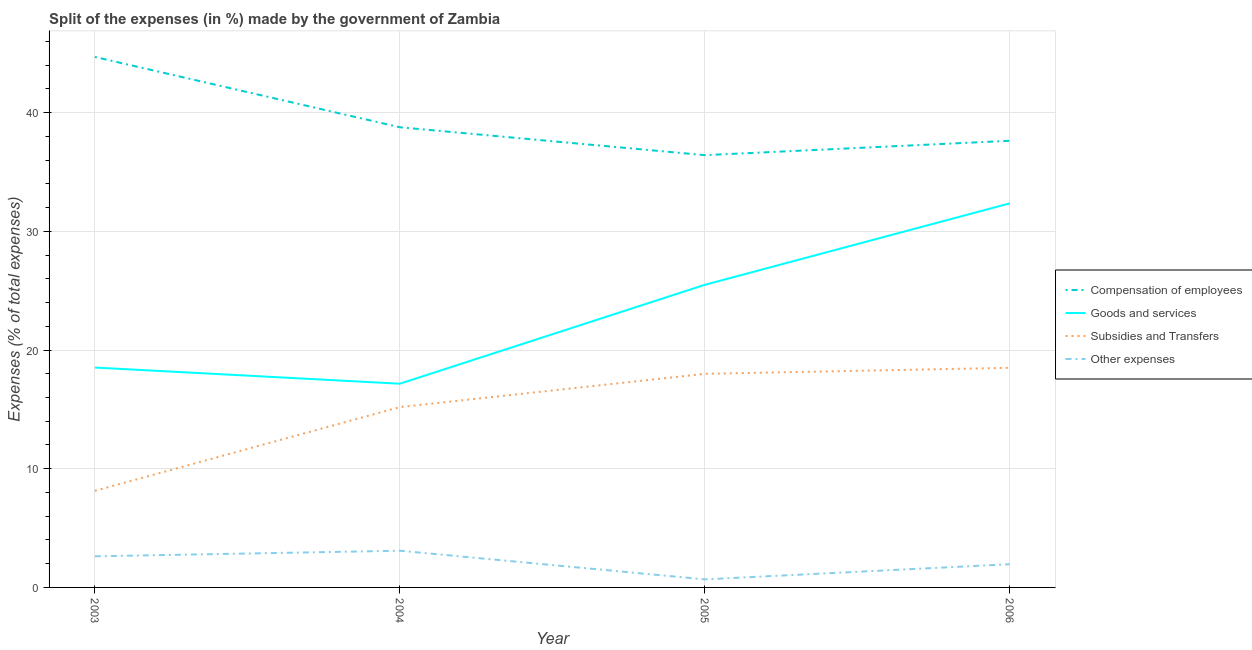How many different coloured lines are there?
Provide a short and direct response. 4. Is the number of lines equal to the number of legend labels?
Provide a short and direct response. Yes. What is the percentage of amount spent on compensation of employees in 2006?
Your response must be concise. 37.63. Across all years, what is the maximum percentage of amount spent on other expenses?
Give a very brief answer. 3.09. Across all years, what is the minimum percentage of amount spent on other expenses?
Keep it short and to the point. 0.68. What is the total percentage of amount spent on subsidies in the graph?
Give a very brief answer. 59.83. What is the difference between the percentage of amount spent on subsidies in 2003 and that in 2004?
Your response must be concise. -7.05. What is the difference between the percentage of amount spent on compensation of employees in 2006 and the percentage of amount spent on goods and services in 2005?
Offer a terse response. 12.13. What is the average percentage of amount spent on goods and services per year?
Your answer should be very brief. 23.38. In the year 2006, what is the difference between the percentage of amount spent on subsidies and percentage of amount spent on goods and services?
Offer a very short reply. -13.86. In how many years, is the percentage of amount spent on goods and services greater than 24 %?
Give a very brief answer. 2. What is the ratio of the percentage of amount spent on compensation of employees in 2005 to that in 2006?
Offer a very short reply. 0.97. Is the percentage of amount spent on compensation of employees in 2004 less than that in 2005?
Ensure brevity in your answer.  No. What is the difference between the highest and the second highest percentage of amount spent on other expenses?
Give a very brief answer. 0.47. What is the difference between the highest and the lowest percentage of amount spent on other expenses?
Offer a very short reply. 2.41. Is the percentage of amount spent on compensation of employees strictly greater than the percentage of amount spent on other expenses over the years?
Provide a succinct answer. Yes. How many lines are there?
Offer a terse response. 4. How many years are there in the graph?
Keep it short and to the point. 4. What is the difference between two consecutive major ticks on the Y-axis?
Your answer should be compact. 10. Are the values on the major ticks of Y-axis written in scientific E-notation?
Offer a very short reply. No. Does the graph contain any zero values?
Offer a terse response. No. Where does the legend appear in the graph?
Your response must be concise. Center right. How many legend labels are there?
Keep it short and to the point. 4. What is the title of the graph?
Keep it short and to the point. Split of the expenses (in %) made by the government of Zambia. What is the label or title of the Y-axis?
Provide a short and direct response. Expenses (% of total expenses). What is the Expenses (% of total expenses) of Compensation of employees in 2003?
Your answer should be compact. 44.69. What is the Expenses (% of total expenses) of Goods and services in 2003?
Your answer should be compact. 18.52. What is the Expenses (% of total expenses) of Subsidies and Transfers in 2003?
Make the answer very short. 8.14. What is the Expenses (% of total expenses) of Other expenses in 2003?
Your response must be concise. 2.62. What is the Expenses (% of total expenses) of Compensation of employees in 2004?
Keep it short and to the point. 38.77. What is the Expenses (% of total expenses) in Goods and services in 2004?
Provide a short and direct response. 17.16. What is the Expenses (% of total expenses) of Subsidies and Transfers in 2004?
Ensure brevity in your answer.  15.19. What is the Expenses (% of total expenses) in Other expenses in 2004?
Offer a very short reply. 3.09. What is the Expenses (% of total expenses) in Compensation of employees in 2005?
Provide a succinct answer. 36.42. What is the Expenses (% of total expenses) of Goods and services in 2005?
Provide a short and direct response. 25.49. What is the Expenses (% of total expenses) of Subsidies and Transfers in 2005?
Your response must be concise. 18. What is the Expenses (% of total expenses) of Other expenses in 2005?
Offer a very short reply. 0.68. What is the Expenses (% of total expenses) of Compensation of employees in 2006?
Offer a very short reply. 37.63. What is the Expenses (% of total expenses) in Goods and services in 2006?
Ensure brevity in your answer.  32.36. What is the Expenses (% of total expenses) in Subsidies and Transfers in 2006?
Your answer should be compact. 18.5. What is the Expenses (% of total expenses) of Other expenses in 2006?
Give a very brief answer. 1.96. Across all years, what is the maximum Expenses (% of total expenses) in Compensation of employees?
Provide a short and direct response. 44.69. Across all years, what is the maximum Expenses (% of total expenses) in Goods and services?
Keep it short and to the point. 32.36. Across all years, what is the maximum Expenses (% of total expenses) of Subsidies and Transfers?
Your response must be concise. 18.5. Across all years, what is the maximum Expenses (% of total expenses) in Other expenses?
Your response must be concise. 3.09. Across all years, what is the minimum Expenses (% of total expenses) of Compensation of employees?
Offer a very short reply. 36.42. Across all years, what is the minimum Expenses (% of total expenses) in Goods and services?
Keep it short and to the point. 17.16. Across all years, what is the minimum Expenses (% of total expenses) in Subsidies and Transfers?
Your answer should be compact. 8.14. Across all years, what is the minimum Expenses (% of total expenses) of Other expenses?
Give a very brief answer. 0.68. What is the total Expenses (% of total expenses) in Compensation of employees in the graph?
Give a very brief answer. 157.51. What is the total Expenses (% of total expenses) of Goods and services in the graph?
Offer a very short reply. 93.54. What is the total Expenses (% of total expenses) in Subsidies and Transfers in the graph?
Make the answer very short. 59.83. What is the total Expenses (% of total expenses) of Other expenses in the graph?
Offer a very short reply. 8.35. What is the difference between the Expenses (% of total expenses) of Compensation of employees in 2003 and that in 2004?
Offer a very short reply. 5.92. What is the difference between the Expenses (% of total expenses) in Goods and services in 2003 and that in 2004?
Ensure brevity in your answer.  1.36. What is the difference between the Expenses (% of total expenses) in Subsidies and Transfers in 2003 and that in 2004?
Keep it short and to the point. -7.05. What is the difference between the Expenses (% of total expenses) in Other expenses in 2003 and that in 2004?
Make the answer very short. -0.47. What is the difference between the Expenses (% of total expenses) in Compensation of employees in 2003 and that in 2005?
Your response must be concise. 8.27. What is the difference between the Expenses (% of total expenses) of Goods and services in 2003 and that in 2005?
Make the answer very short. -6.97. What is the difference between the Expenses (% of total expenses) of Subsidies and Transfers in 2003 and that in 2005?
Your response must be concise. -9.86. What is the difference between the Expenses (% of total expenses) in Other expenses in 2003 and that in 2005?
Keep it short and to the point. 1.94. What is the difference between the Expenses (% of total expenses) in Compensation of employees in 2003 and that in 2006?
Keep it short and to the point. 7.06. What is the difference between the Expenses (% of total expenses) in Goods and services in 2003 and that in 2006?
Provide a short and direct response. -13.83. What is the difference between the Expenses (% of total expenses) of Subsidies and Transfers in 2003 and that in 2006?
Give a very brief answer. -10.36. What is the difference between the Expenses (% of total expenses) in Other expenses in 2003 and that in 2006?
Your response must be concise. 0.66. What is the difference between the Expenses (% of total expenses) in Compensation of employees in 2004 and that in 2005?
Your answer should be very brief. 2.35. What is the difference between the Expenses (% of total expenses) of Goods and services in 2004 and that in 2005?
Provide a short and direct response. -8.33. What is the difference between the Expenses (% of total expenses) of Subsidies and Transfers in 2004 and that in 2005?
Offer a terse response. -2.8. What is the difference between the Expenses (% of total expenses) of Other expenses in 2004 and that in 2005?
Offer a terse response. 2.42. What is the difference between the Expenses (% of total expenses) in Compensation of employees in 2004 and that in 2006?
Your response must be concise. 1.14. What is the difference between the Expenses (% of total expenses) of Goods and services in 2004 and that in 2006?
Make the answer very short. -15.19. What is the difference between the Expenses (% of total expenses) of Subsidies and Transfers in 2004 and that in 2006?
Offer a terse response. -3.31. What is the difference between the Expenses (% of total expenses) in Other expenses in 2004 and that in 2006?
Ensure brevity in your answer.  1.13. What is the difference between the Expenses (% of total expenses) of Compensation of employees in 2005 and that in 2006?
Your answer should be compact. -1.21. What is the difference between the Expenses (% of total expenses) in Goods and services in 2005 and that in 2006?
Offer a very short reply. -6.86. What is the difference between the Expenses (% of total expenses) in Subsidies and Transfers in 2005 and that in 2006?
Provide a short and direct response. -0.51. What is the difference between the Expenses (% of total expenses) in Other expenses in 2005 and that in 2006?
Provide a succinct answer. -1.28. What is the difference between the Expenses (% of total expenses) in Compensation of employees in 2003 and the Expenses (% of total expenses) in Goods and services in 2004?
Give a very brief answer. 27.53. What is the difference between the Expenses (% of total expenses) in Compensation of employees in 2003 and the Expenses (% of total expenses) in Subsidies and Transfers in 2004?
Make the answer very short. 29.5. What is the difference between the Expenses (% of total expenses) in Compensation of employees in 2003 and the Expenses (% of total expenses) in Other expenses in 2004?
Your answer should be very brief. 41.6. What is the difference between the Expenses (% of total expenses) in Goods and services in 2003 and the Expenses (% of total expenses) in Subsidies and Transfers in 2004?
Your response must be concise. 3.33. What is the difference between the Expenses (% of total expenses) of Goods and services in 2003 and the Expenses (% of total expenses) of Other expenses in 2004?
Your answer should be compact. 15.43. What is the difference between the Expenses (% of total expenses) of Subsidies and Transfers in 2003 and the Expenses (% of total expenses) of Other expenses in 2004?
Offer a very short reply. 5.04. What is the difference between the Expenses (% of total expenses) in Compensation of employees in 2003 and the Expenses (% of total expenses) in Goods and services in 2005?
Keep it short and to the point. 19.2. What is the difference between the Expenses (% of total expenses) of Compensation of employees in 2003 and the Expenses (% of total expenses) of Subsidies and Transfers in 2005?
Your answer should be compact. 26.7. What is the difference between the Expenses (% of total expenses) in Compensation of employees in 2003 and the Expenses (% of total expenses) in Other expenses in 2005?
Keep it short and to the point. 44.01. What is the difference between the Expenses (% of total expenses) in Goods and services in 2003 and the Expenses (% of total expenses) in Subsidies and Transfers in 2005?
Offer a terse response. 0.53. What is the difference between the Expenses (% of total expenses) of Goods and services in 2003 and the Expenses (% of total expenses) of Other expenses in 2005?
Keep it short and to the point. 17.85. What is the difference between the Expenses (% of total expenses) of Subsidies and Transfers in 2003 and the Expenses (% of total expenses) of Other expenses in 2005?
Keep it short and to the point. 7.46. What is the difference between the Expenses (% of total expenses) in Compensation of employees in 2003 and the Expenses (% of total expenses) in Goods and services in 2006?
Your answer should be very brief. 12.33. What is the difference between the Expenses (% of total expenses) of Compensation of employees in 2003 and the Expenses (% of total expenses) of Subsidies and Transfers in 2006?
Ensure brevity in your answer.  26.19. What is the difference between the Expenses (% of total expenses) of Compensation of employees in 2003 and the Expenses (% of total expenses) of Other expenses in 2006?
Your answer should be compact. 42.73. What is the difference between the Expenses (% of total expenses) in Goods and services in 2003 and the Expenses (% of total expenses) in Subsidies and Transfers in 2006?
Offer a terse response. 0.02. What is the difference between the Expenses (% of total expenses) of Goods and services in 2003 and the Expenses (% of total expenses) of Other expenses in 2006?
Ensure brevity in your answer.  16.57. What is the difference between the Expenses (% of total expenses) in Subsidies and Transfers in 2003 and the Expenses (% of total expenses) in Other expenses in 2006?
Ensure brevity in your answer.  6.18. What is the difference between the Expenses (% of total expenses) of Compensation of employees in 2004 and the Expenses (% of total expenses) of Goods and services in 2005?
Provide a short and direct response. 13.27. What is the difference between the Expenses (% of total expenses) of Compensation of employees in 2004 and the Expenses (% of total expenses) of Subsidies and Transfers in 2005?
Provide a short and direct response. 20.77. What is the difference between the Expenses (% of total expenses) in Compensation of employees in 2004 and the Expenses (% of total expenses) in Other expenses in 2005?
Offer a terse response. 38.09. What is the difference between the Expenses (% of total expenses) in Goods and services in 2004 and the Expenses (% of total expenses) in Subsidies and Transfers in 2005?
Give a very brief answer. -0.83. What is the difference between the Expenses (% of total expenses) in Goods and services in 2004 and the Expenses (% of total expenses) in Other expenses in 2005?
Provide a short and direct response. 16.49. What is the difference between the Expenses (% of total expenses) of Subsidies and Transfers in 2004 and the Expenses (% of total expenses) of Other expenses in 2005?
Your answer should be very brief. 14.51. What is the difference between the Expenses (% of total expenses) in Compensation of employees in 2004 and the Expenses (% of total expenses) in Goods and services in 2006?
Ensure brevity in your answer.  6.41. What is the difference between the Expenses (% of total expenses) in Compensation of employees in 2004 and the Expenses (% of total expenses) in Subsidies and Transfers in 2006?
Provide a short and direct response. 20.27. What is the difference between the Expenses (% of total expenses) in Compensation of employees in 2004 and the Expenses (% of total expenses) in Other expenses in 2006?
Provide a succinct answer. 36.81. What is the difference between the Expenses (% of total expenses) of Goods and services in 2004 and the Expenses (% of total expenses) of Subsidies and Transfers in 2006?
Provide a succinct answer. -1.34. What is the difference between the Expenses (% of total expenses) in Goods and services in 2004 and the Expenses (% of total expenses) in Other expenses in 2006?
Offer a very short reply. 15.2. What is the difference between the Expenses (% of total expenses) in Subsidies and Transfers in 2004 and the Expenses (% of total expenses) in Other expenses in 2006?
Make the answer very short. 13.23. What is the difference between the Expenses (% of total expenses) in Compensation of employees in 2005 and the Expenses (% of total expenses) in Goods and services in 2006?
Make the answer very short. 4.06. What is the difference between the Expenses (% of total expenses) in Compensation of employees in 2005 and the Expenses (% of total expenses) in Subsidies and Transfers in 2006?
Provide a short and direct response. 17.92. What is the difference between the Expenses (% of total expenses) of Compensation of employees in 2005 and the Expenses (% of total expenses) of Other expenses in 2006?
Your answer should be very brief. 34.46. What is the difference between the Expenses (% of total expenses) of Goods and services in 2005 and the Expenses (% of total expenses) of Subsidies and Transfers in 2006?
Offer a terse response. 6.99. What is the difference between the Expenses (% of total expenses) in Goods and services in 2005 and the Expenses (% of total expenses) in Other expenses in 2006?
Your response must be concise. 23.54. What is the difference between the Expenses (% of total expenses) of Subsidies and Transfers in 2005 and the Expenses (% of total expenses) of Other expenses in 2006?
Your answer should be compact. 16.04. What is the average Expenses (% of total expenses) of Compensation of employees per year?
Your answer should be compact. 39.38. What is the average Expenses (% of total expenses) of Goods and services per year?
Keep it short and to the point. 23.38. What is the average Expenses (% of total expenses) of Subsidies and Transfers per year?
Ensure brevity in your answer.  14.96. What is the average Expenses (% of total expenses) in Other expenses per year?
Provide a short and direct response. 2.09. In the year 2003, what is the difference between the Expenses (% of total expenses) in Compensation of employees and Expenses (% of total expenses) in Goods and services?
Provide a short and direct response. 26.17. In the year 2003, what is the difference between the Expenses (% of total expenses) in Compensation of employees and Expenses (% of total expenses) in Subsidies and Transfers?
Offer a terse response. 36.55. In the year 2003, what is the difference between the Expenses (% of total expenses) in Compensation of employees and Expenses (% of total expenses) in Other expenses?
Your answer should be very brief. 42.07. In the year 2003, what is the difference between the Expenses (% of total expenses) in Goods and services and Expenses (% of total expenses) in Subsidies and Transfers?
Your answer should be very brief. 10.39. In the year 2003, what is the difference between the Expenses (% of total expenses) in Goods and services and Expenses (% of total expenses) in Other expenses?
Offer a terse response. 15.9. In the year 2003, what is the difference between the Expenses (% of total expenses) of Subsidies and Transfers and Expenses (% of total expenses) of Other expenses?
Your answer should be compact. 5.52. In the year 2004, what is the difference between the Expenses (% of total expenses) in Compensation of employees and Expenses (% of total expenses) in Goods and services?
Provide a short and direct response. 21.61. In the year 2004, what is the difference between the Expenses (% of total expenses) in Compensation of employees and Expenses (% of total expenses) in Subsidies and Transfers?
Provide a succinct answer. 23.58. In the year 2004, what is the difference between the Expenses (% of total expenses) of Compensation of employees and Expenses (% of total expenses) of Other expenses?
Your answer should be compact. 35.68. In the year 2004, what is the difference between the Expenses (% of total expenses) in Goods and services and Expenses (% of total expenses) in Subsidies and Transfers?
Provide a short and direct response. 1.97. In the year 2004, what is the difference between the Expenses (% of total expenses) in Goods and services and Expenses (% of total expenses) in Other expenses?
Offer a terse response. 14.07. In the year 2004, what is the difference between the Expenses (% of total expenses) of Subsidies and Transfers and Expenses (% of total expenses) of Other expenses?
Ensure brevity in your answer.  12.1. In the year 2005, what is the difference between the Expenses (% of total expenses) in Compensation of employees and Expenses (% of total expenses) in Goods and services?
Provide a short and direct response. 10.92. In the year 2005, what is the difference between the Expenses (% of total expenses) in Compensation of employees and Expenses (% of total expenses) in Subsidies and Transfers?
Offer a terse response. 18.42. In the year 2005, what is the difference between the Expenses (% of total expenses) of Compensation of employees and Expenses (% of total expenses) of Other expenses?
Offer a terse response. 35.74. In the year 2005, what is the difference between the Expenses (% of total expenses) of Goods and services and Expenses (% of total expenses) of Subsidies and Transfers?
Your answer should be compact. 7.5. In the year 2005, what is the difference between the Expenses (% of total expenses) in Goods and services and Expenses (% of total expenses) in Other expenses?
Provide a succinct answer. 24.82. In the year 2005, what is the difference between the Expenses (% of total expenses) in Subsidies and Transfers and Expenses (% of total expenses) in Other expenses?
Give a very brief answer. 17.32. In the year 2006, what is the difference between the Expenses (% of total expenses) in Compensation of employees and Expenses (% of total expenses) in Goods and services?
Offer a very short reply. 5.27. In the year 2006, what is the difference between the Expenses (% of total expenses) in Compensation of employees and Expenses (% of total expenses) in Subsidies and Transfers?
Provide a succinct answer. 19.13. In the year 2006, what is the difference between the Expenses (% of total expenses) of Compensation of employees and Expenses (% of total expenses) of Other expenses?
Your answer should be compact. 35.67. In the year 2006, what is the difference between the Expenses (% of total expenses) in Goods and services and Expenses (% of total expenses) in Subsidies and Transfers?
Your answer should be very brief. 13.86. In the year 2006, what is the difference between the Expenses (% of total expenses) in Goods and services and Expenses (% of total expenses) in Other expenses?
Offer a terse response. 30.4. In the year 2006, what is the difference between the Expenses (% of total expenses) of Subsidies and Transfers and Expenses (% of total expenses) of Other expenses?
Ensure brevity in your answer.  16.54. What is the ratio of the Expenses (% of total expenses) of Compensation of employees in 2003 to that in 2004?
Make the answer very short. 1.15. What is the ratio of the Expenses (% of total expenses) in Goods and services in 2003 to that in 2004?
Keep it short and to the point. 1.08. What is the ratio of the Expenses (% of total expenses) in Subsidies and Transfers in 2003 to that in 2004?
Offer a terse response. 0.54. What is the ratio of the Expenses (% of total expenses) in Other expenses in 2003 to that in 2004?
Provide a succinct answer. 0.85. What is the ratio of the Expenses (% of total expenses) in Compensation of employees in 2003 to that in 2005?
Provide a short and direct response. 1.23. What is the ratio of the Expenses (% of total expenses) in Goods and services in 2003 to that in 2005?
Offer a very short reply. 0.73. What is the ratio of the Expenses (% of total expenses) of Subsidies and Transfers in 2003 to that in 2005?
Provide a succinct answer. 0.45. What is the ratio of the Expenses (% of total expenses) in Other expenses in 2003 to that in 2005?
Your answer should be compact. 3.87. What is the ratio of the Expenses (% of total expenses) in Compensation of employees in 2003 to that in 2006?
Ensure brevity in your answer.  1.19. What is the ratio of the Expenses (% of total expenses) in Goods and services in 2003 to that in 2006?
Ensure brevity in your answer.  0.57. What is the ratio of the Expenses (% of total expenses) of Subsidies and Transfers in 2003 to that in 2006?
Your answer should be very brief. 0.44. What is the ratio of the Expenses (% of total expenses) of Other expenses in 2003 to that in 2006?
Ensure brevity in your answer.  1.34. What is the ratio of the Expenses (% of total expenses) of Compensation of employees in 2004 to that in 2005?
Offer a terse response. 1.06. What is the ratio of the Expenses (% of total expenses) of Goods and services in 2004 to that in 2005?
Offer a very short reply. 0.67. What is the ratio of the Expenses (% of total expenses) of Subsidies and Transfers in 2004 to that in 2005?
Offer a terse response. 0.84. What is the ratio of the Expenses (% of total expenses) of Other expenses in 2004 to that in 2005?
Offer a very short reply. 4.57. What is the ratio of the Expenses (% of total expenses) of Compensation of employees in 2004 to that in 2006?
Provide a succinct answer. 1.03. What is the ratio of the Expenses (% of total expenses) in Goods and services in 2004 to that in 2006?
Provide a succinct answer. 0.53. What is the ratio of the Expenses (% of total expenses) in Subsidies and Transfers in 2004 to that in 2006?
Provide a short and direct response. 0.82. What is the ratio of the Expenses (% of total expenses) in Other expenses in 2004 to that in 2006?
Provide a succinct answer. 1.58. What is the ratio of the Expenses (% of total expenses) of Compensation of employees in 2005 to that in 2006?
Ensure brevity in your answer.  0.97. What is the ratio of the Expenses (% of total expenses) in Goods and services in 2005 to that in 2006?
Your answer should be compact. 0.79. What is the ratio of the Expenses (% of total expenses) of Subsidies and Transfers in 2005 to that in 2006?
Make the answer very short. 0.97. What is the ratio of the Expenses (% of total expenses) in Other expenses in 2005 to that in 2006?
Make the answer very short. 0.35. What is the difference between the highest and the second highest Expenses (% of total expenses) in Compensation of employees?
Provide a short and direct response. 5.92. What is the difference between the highest and the second highest Expenses (% of total expenses) in Goods and services?
Provide a succinct answer. 6.86. What is the difference between the highest and the second highest Expenses (% of total expenses) in Subsidies and Transfers?
Your response must be concise. 0.51. What is the difference between the highest and the second highest Expenses (% of total expenses) in Other expenses?
Keep it short and to the point. 0.47. What is the difference between the highest and the lowest Expenses (% of total expenses) of Compensation of employees?
Your answer should be compact. 8.27. What is the difference between the highest and the lowest Expenses (% of total expenses) in Goods and services?
Offer a very short reply. 15.19. What is the difference between the highest and the lowest Expenses (% of total expenses) of Subsidies and Transfers?
Give a very brief answer. 10.36. What is the difference between the highest and the lowest Expenses (% of total expenses) of Other expenses?
Provide a succinct answer. 2.42. 